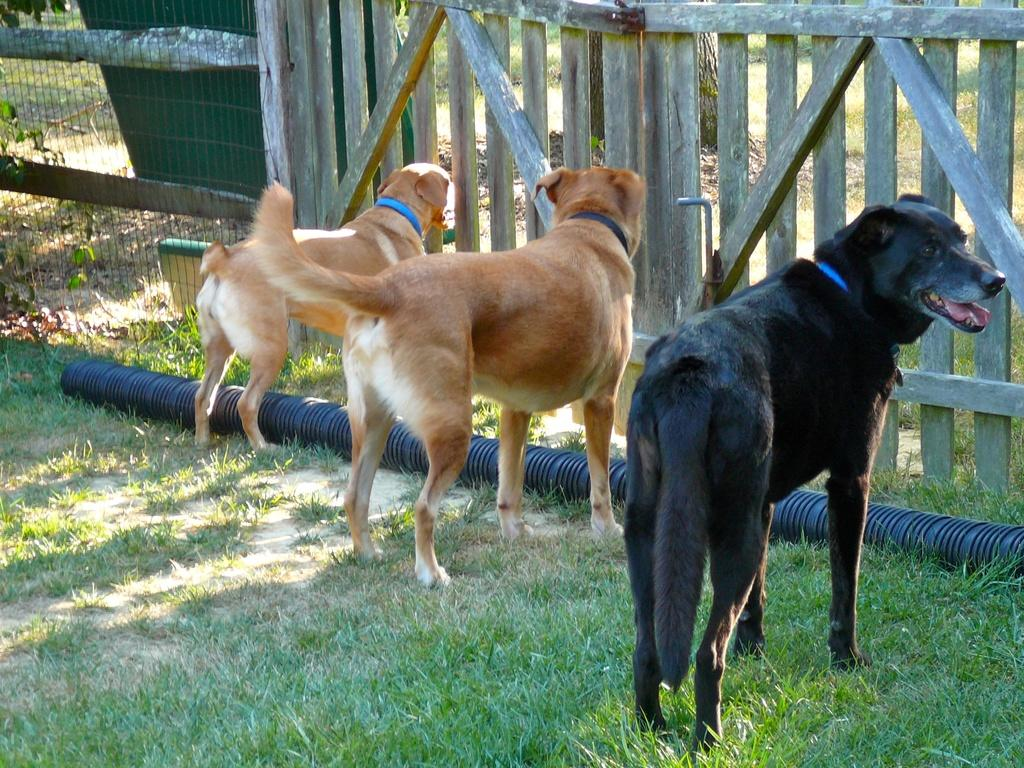What animals can be seen in the image? There are dogs in the image. Where are the dogs located? The dogs are in a cage. What type of natural environment is visible in the image? There is grass visible in the image. What type of letter is being written by the dog in the image? There is no dog writing a letter in the image; the dogs are in a cage. Can you see any corn growing in the image? There is no corn visible in the image; only grass is mentioned. 